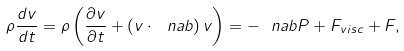<formula> <loc_0><loc_0><loc_500><loc_500>\rho \frac { d { v } } { d t } = \rho \left ( \frac { \partial { v } } { \partial t } + \left ( { v } \cdot \ n a b \right ) { v } \right ) = - \ n a b P + { F } _ { v i s c } + { F } ,</formula> 